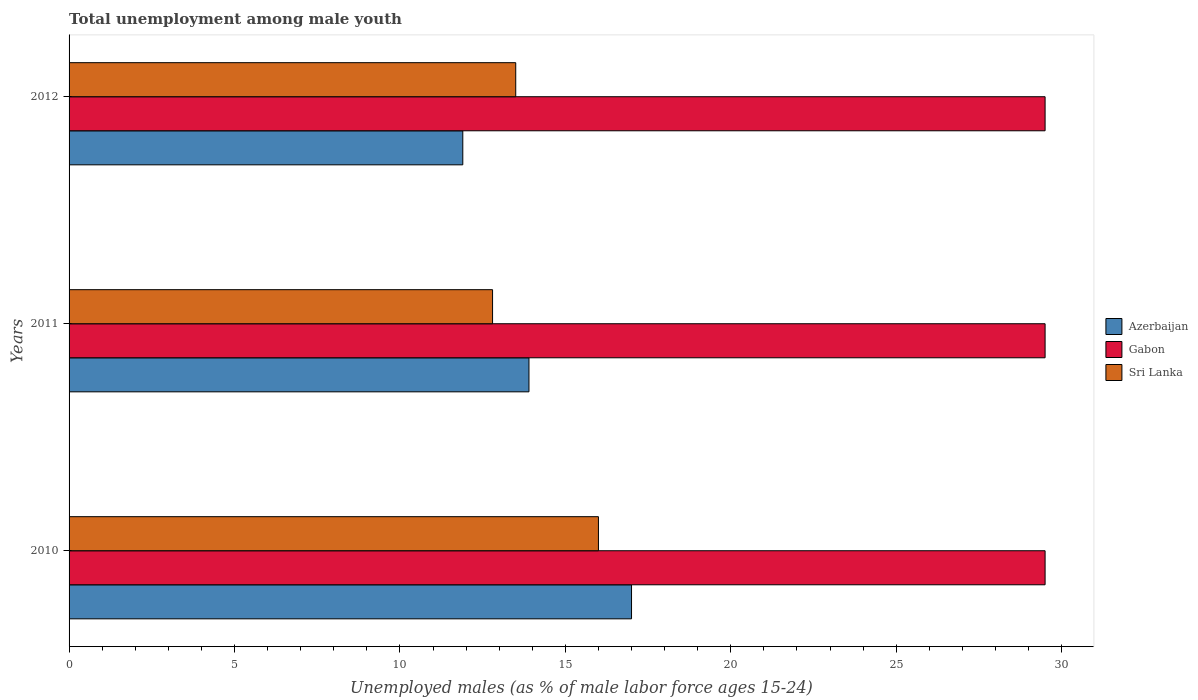How many groups of bars are there?
Ensure brevity in your answer.  3. Are the number of bars per tick equal to the number of legend labels?
Your response must be concise. Yes. Are the number of bars on each tick of the Y-axis equal?
Your answer should be compact. Yes. What is the label of the 3rd group of bars from the top?
Your answer should be compact. 2010. In how many cases, is the number of bars for a given year not equal to the number of legend labels?
Keep it short and to the point. 0. What is the percentage of unemployed males in in Gabon in 2011?
Your answer should be very brief. 29.5. Across all years, what is the maximum percentage of unemployed males in in Gabon?
Provide a short and direct response. 29.5. Across all years, what is the minimum percentage of unemployed males in in Gabon?
Your response must be concise. 29.5. In which year was the percentage of unemployed males in in Sri Lanka maximum?
Provide a succinct answer. 2010. What is the total percentage of unemployed males in in Azerbaijan in the graph?
Keep it short and to the point. 42.8. What is the difference between the percentage of unemployed males in in Gabon in 2010 and that in 2011?
Give a very brief answer. 0. What is the difference between the percentage of unemployed males in in Azerbaijan in 2010 and the percentage of unemployed males in in Gabon in 2012?
Your response must be concise. -12.5. What is the average percentage of unemployed males in in Sri Lanka per year?
Make the answer very short. 14.1. In the year 2012, what is the difference between the percentage of unemployed males in in Sri Lanka and percentage of unemployed males in in Azerbaijan?
Make the answer very short. 1.6. What is the ratio of the percentage of unemployed males in in Azerbaijan in 2010 to that in 2012?
Keep it short and to the point. 1.43. Is the percentage of unemployed males in in Gabon in 2011 less than that in 2012?
Your answer should be very brief. No. What is the difference between the highest and the second highest percentage of unemployed males in in Azerbaijan?
Give a very brief answer. 3.1. What is the difference between the highest and the lowest percentage of unemployed males in in Azerbaijan?
Offer a terse response. 5.1. What does the 3rd bar from the top in 2011 represents?
Keep it short and to the point. Azerbaijan. What does the 2nd bar from the bottom in 2010 represents?
Keep it short and to the point. Gabon. Are the values on the major ticks of X-axis written in scientific E-notation?
Ensure brevity in your answer.  No. What is the title of the graph?
Provide a succinct answer. Total unemployment among male youth. What is the label or title of the X-axis?
Provide a succinct answer. Unemployed males (as % of male labor force ages 15-24). What is the label or title of the Y-axis?
Provide a short and direct response. Years. What is the Unemployed males (as % of male labor force ages 15-24) of Gabon in 2010?
Provide a short and direct response. 29.5. What is the Unemployed males (as % of male labor force ages 15-24) in Azerbaijan in 2011?
Give a very brief answer. 13.9. What is the Unemployed males (as % of male labor force ages 15-24) of Gabon in 2011?
Make the answer very short. 29.5. What is the Unemployed males (as % of male labor force ages 15-24) of Sri Lanka in 2011?
Your answer should be very brief. 12.8. What is the Unemployed males (as % of male labor force ages 15-24) of Azerbaijan in 2012?
Keep it short and to the point. 11.9. What is the Unemployed males (as % of male labor force ages 15-24) of Gabon in 2012?
Provide a short and direct response. 29.5. What is the Unemployed males (as % of male labor force ages 15-24) of Sri Lanka in 2012?
Keep it short and to the point. 13.5. Across all years, what is the maximum Unemployed males (as % of male labor force ages 15-24) of Gabon?
Your answer should be compact. 29.5. Across all years, what is the maximum Unemployed males (as % of male labor force ages 15-24) of Sri Lanka?
Offer a terse response. 16. Across all years, what is the minimum Unemployed males (as % of male labor force ages 15-24) in Azerbaijan?
Your answer should be very brief. 11.9. Across all years, what is the minimum Unemployed males (as % of male labor force ages 15-24) of Gabon?
Offer a terse response. 29.5. Across all years, what is the minimum Unemployed males (as % of male labor force ages 15-24) of Sri Lanka?
Give a very brief answer. 12.8. What is the total Unemployed males (as % of male labor force ages 15-24) in Azerbaijan in the graph?
Give a very brief answer. 42.8. What is the total Unemployed males (as % of male labor force ages 15-24) in Gabon in the graph?
Offer a very short reply. 88.5. What is the total Unemployed males (as % of male labor force ages 15-24) in Sri Lanka in the graph?
Your response must be concise. 42.3. What is the difference between the Unemployed males (as % of male labor force ages 15-24) of Gabon in 2010 and that in 2011?
Your answer should be compact. 0. What is the difference between the Unemployed males (as % of male labor force ages 15-24) of Sri Lanka in 2010 and that in 2012?
Your answer should be very brief. 2.5. What is the difference between the Unemployed males (as % of male labor force ages 15-24) in Gabon in 2011 and that in 2012?
Give a very brief answer. 0. What is the difference between the Unemployed males (as % of male labor force ages 15-24) in Sri Lanka in 2011 and that in 2012?
Your answer should be compact. -0.7. What is the difference between the Unemployed males (as % of male labor force ages 15-24) in Azerbaijan in 2010 and the Unemployed males (as % of male labor force ages 15-24) in Gabon in 2011?
Provide a short and direct response. -12.5. What is the difference between the Unemployed males (as % of male labor force ages 15-24) of Azerbaijan in 2011 and the Unemployed males (as % of male labor force ages 15-24) of Gabon in 2012?
Offer a terse response. -15.6. What is the difference between the Unemployed males (as % of male labor force ages 15-24) of Azerbaijan in 2011 and the Unemployed males (as % of male labor force ages 15-24) of Sri Lanka in 2012?
Provide a succinct answer. 0.4. What is the difference between the Unemployed males (as % of male labor force ages 15-24) of Gabon in 2011 and the Unemployed males (as % of male labor force ages 15-24) of Sri Lanka in 2012?
Your answer should be compact. 16. What is the average Unemployed males (as % of male labor force ages 15-24) of Azerbaijan per year?
Offer a very short reply. 14.27. What is the average Unemployed males (as % of male labor force ages 15-24) of Gabon per year?
Your answer should be very brief. 29.5. In the year 2010, what is the difference between the Unemployed males (as % of male labor force ages 15-24) in Azerbaijan and Unemployed males (as % of male labor force ages 15-24) in Gabon?
Your answer should be compact. -12.5. In the year 2010, what is the difference between the Unemployed males (as % of male labor force ages 15-24) of Gabon and Unemployed males (as % of male labor force ages 15-24) of Sri Lanka?
Provide a succinct answer. 13.5. In the year 2011, what is the difference between the Unemployed males (as % of male labor force ages 15-24) in Azerbaijan and Unemployed males (as % of male labor force ages 15-24) in Gabon?
Offer a very short reply. -15.6. In the year 2012, what is the difference between the Unemployed males (as % of male labor force ages 15-24) in Azerbaijan and Unemployed males (as % of male labor force ages 15-24) in Gabon?
Offer a very short reply. -17.6. In the year 2012, what is the difference between the Unemployed males (as % of male labor force ages 15-24) of Gabon and Unemployed males (as % of male labor force ages 15-24) of Sri Lanka?
Offer a terse response. 16. What is the ratio of the Unemployed males (as % of male labor force ages 15-24) in Azerbaijan in 2010 to that in 2011?
Offer a very short reply. 1.22. What is the ratio of the Unemployed males (as % of male labor force ages 15-24) in Gabon in 2010 to that in 2011?
Offer a very short reply. 1. What is the ratio of the Unemployed males (as % of male labor force ages 15-24) in Sri Lanka in 2010 to that in 2011?
Provide a short and direct response. 1.25. What is the ratio of the Unemployed males (as % of male labor force ages 15-24) of Azerbaijan in 2010 to that in 2012?
Provide a short and direct response. 1.43. What is the ratio of the Unemployed males (as % of male labor force ages 15-24) of Sri Lanka in 2010 to that in 2012?
Make the answer very short. 1.19. What is the ratio of the Unemployed males (as % of male labor force ages 15-24) of Azerbaijan in 2011 to that in 2012?
Your answer should be compact. 1.17. What is the ratio of the Unemployed males (as % of male labor force ages 15-24) in Gabon in 2011 to that in 2012?
Your answer should be very brief. 1. What is the ratio of the Unemployed males (as % of male labor force ages 15-24) in Sri Lanka in 2011 to that in 2012?
Provide a short and direct response. 0.95. What is the difference between the highest and the second highest Unemployed males (as % of male labor force ages 15-24) of Azerbaijan?
Your answer should be very brief. 3.1. What is the difference between the highest and the lowest Unemployed males (as % of male labor force ages 15-24) of Azerbaijan?
Offer a very short reply. 5.1. What is the difference between the highest and the lowest Unemployed males (as % of male labor force ages 15-24) of Gabon?
Your response must be concise. 0. 